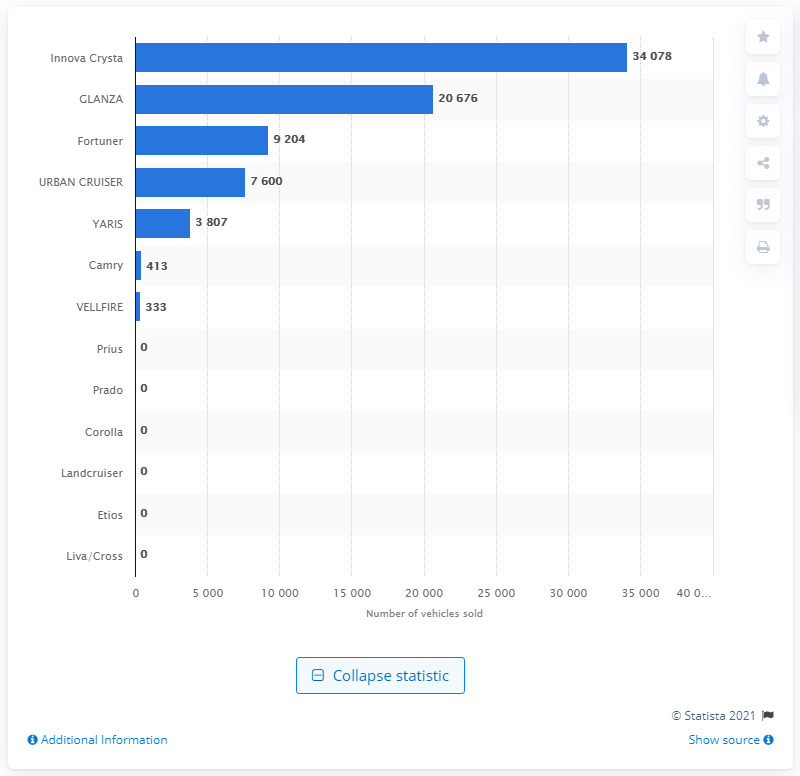Specify some key components in this picture. In 2020, a total of 34,078 units of the Toyota Innova Crysta were sold in India. 